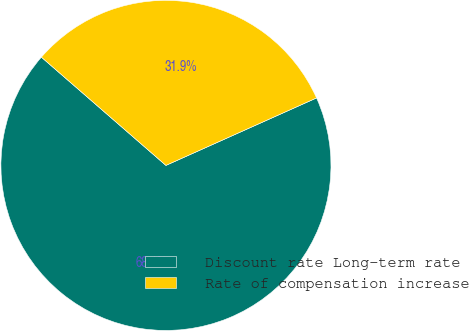Convert chart. <chart><loc_0><loc_0><loc_500><loc_500><pie_chart><fcel>Discount rate Long-term rate<fcel>Rate of compensation increase<nl><fcel>68.09%<fcel>31.91%<nl></chart> 